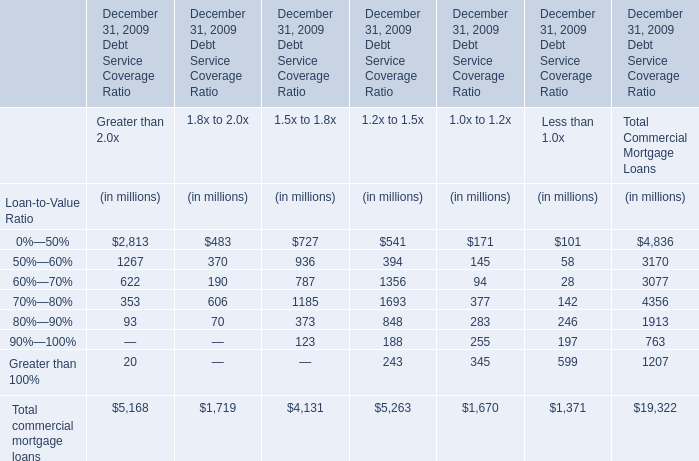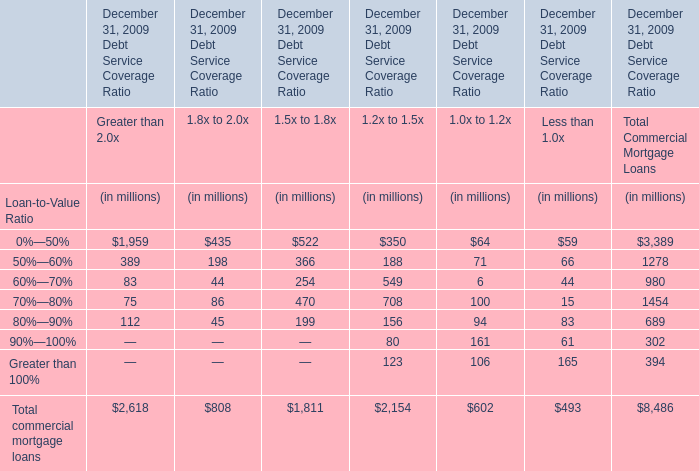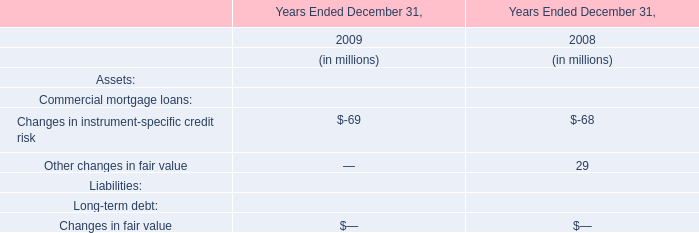What is the lowest value of Total Commercial Mortgage Loans as As the chart 0 shows? (in million) 
Answer: 763. 